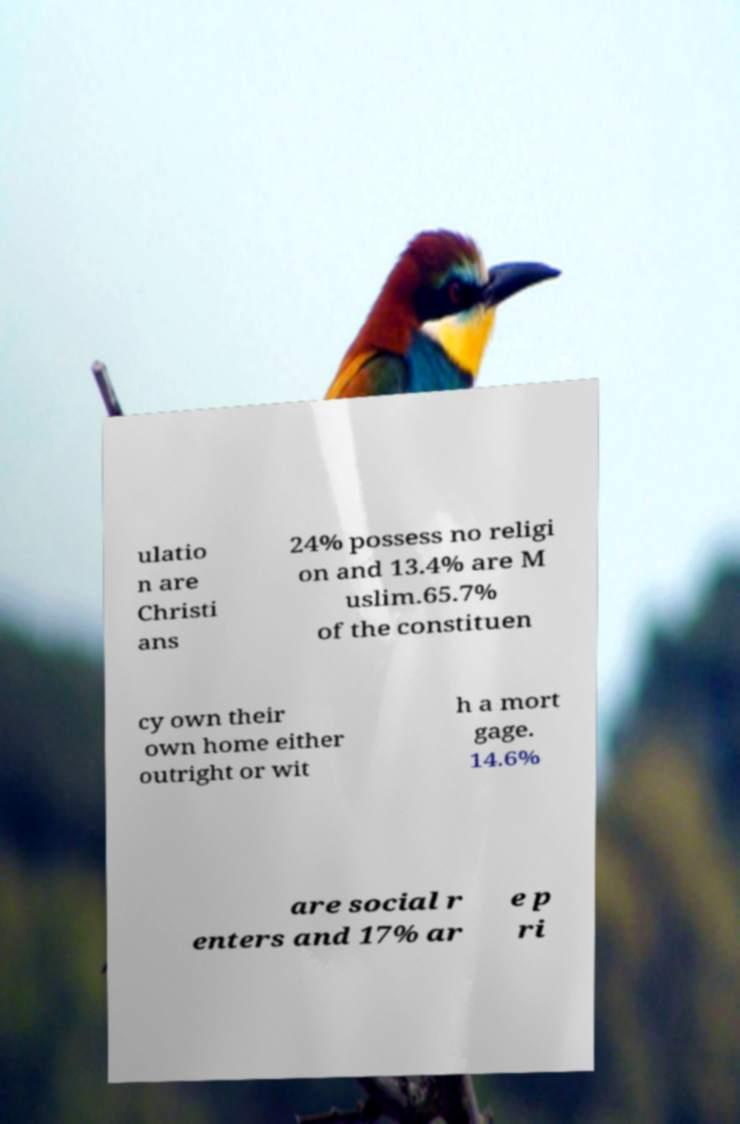Please identify and transcribe the text found in this image. ulatio n are Christi ans 24% possess no religi on and 13.4% are M uslim.65.7% of the constituen cy own their own home either outright or wit h a mort gage. 14.6% are social r enters and 17% ar e p ri 